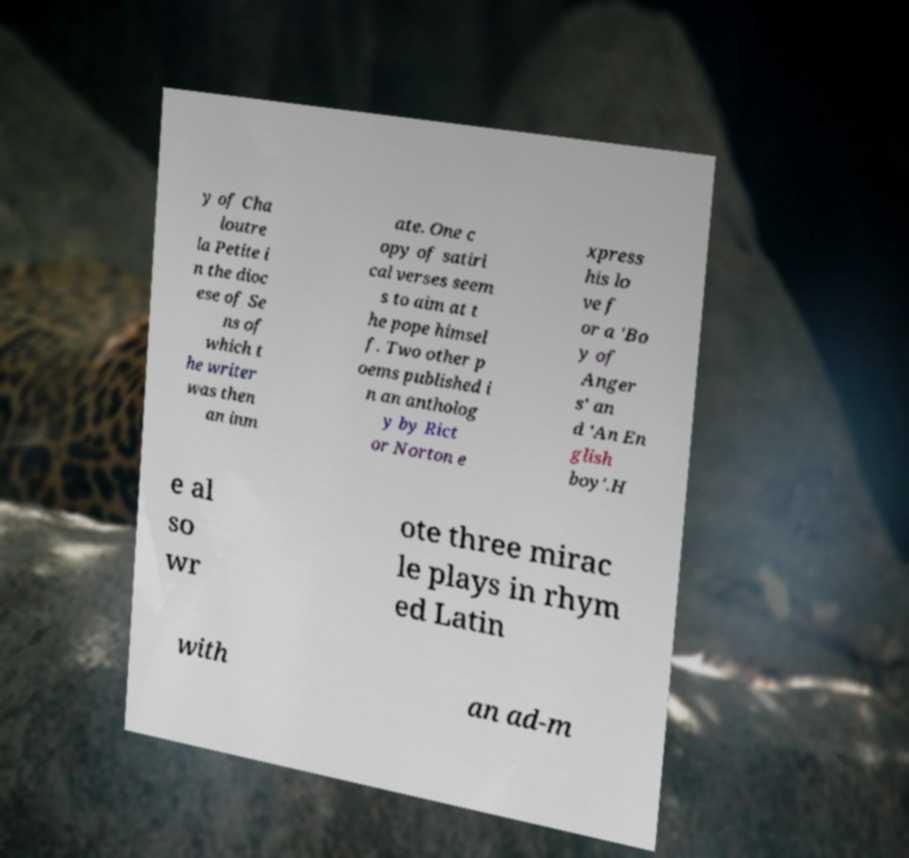There's text embedded in this image that I need extracted. Can you transcribe it verbatim? y of Cha loutre la Petite i n the dioc ese of Se ns of which t he writer was then an inm ate. One c opy of satiri cal verses seem s to aim at t he pope himsel f. Two other p oems published i n an antholog y by Rict or Norton e xpress his lo ve f or a 'Bo y of Anger s' an d 'An En glish boy'.H e al so wr ote three mirac le plays in rhym ed Latin with an ad-m 